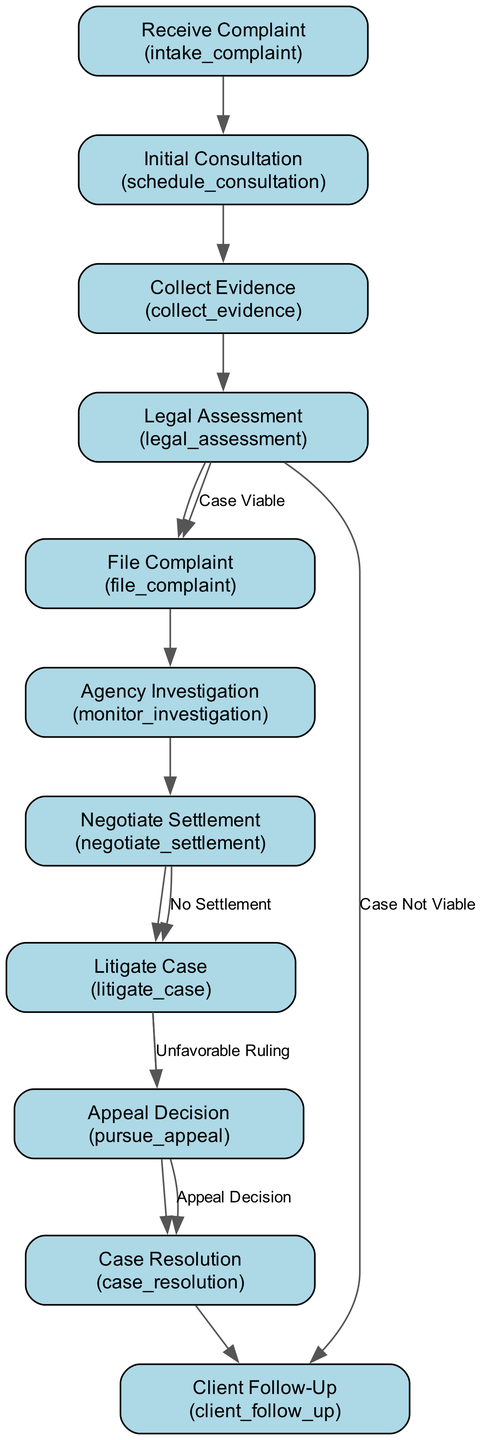What is the first step in the workflow? The first step in the workflow is labeled as "Receive Complaint," which indicates the initial action taken to start handling the case. This is evidenced by the first node in the diagram.
Answer: Receive Complaint How many nodes are present in the diagram? By counting the different steps (or nodes) illustrated in the diagram, we find a total of 11 distinct nodes that represent different processes in handling police misconduct cases.
Answer: 11 What is the outcome if the legal assessment determines the case is not viable? According to the flowchart, if the legal assessment identifies the case is not viable, the workflow directs to the "Client Follow-Up" step, indicating communication about the case's status to the client.
Answer: Client Follow-Up What action is taken after filing a complaint? Once the complaint is filed, the next step in the workflow is "Agency Investigation," which involves monitoring the internal investigation undertaken by the relevant authority. This is shown as the direct follow-up to the "File Complaint" node in the diagram.
Answer: Agency Investigation What happens if settlement negotiations fail? The flowchart specifies that if settlement negotiations do not succeed, the next action is to "Litigate Case," which involves proceeding to civil court actions such as filing a lawsuit. This sequence is indicated by a direct connection from "Negotiate Settlement" to "Litigate Case."
Answer: Litigate Case How many edges connect the nodes in the diagram? By reviewing the connections made between the nodes, we can identify that there are 12 edges that depict the relationships and flow between different steps, indicating the progression through various stages of the case handling process.
Answer: 12 What is the last step in the workflow? The final step highlighted in the diagram is "Case Resolution," marking the conclusion of the case regardless of the outcome, whether through settlement, court ruling, or appeal decision. This can be verified as the last node in the flowchart.
Answer: Case Resolution What is the purpose of the "Collect Evidence" step? The "Collect Evidence" step aims to gather and review various forms of evidence, including witness statements, video footage, and reports, essential for evaluating the case. This step is clearly defined and serves as a foundational part of assessing misconduct.
Answer: Gather and review evidence If a case has an unfavorable ruling, what step follows? If the case results in an unfavorable ruling, the subsequent action outlined in the diagram is to "Appeal Decision," indicating that there is a provision for seeking redress in a higher court for any unjust decisions made.
Answer: Appeal Decision 